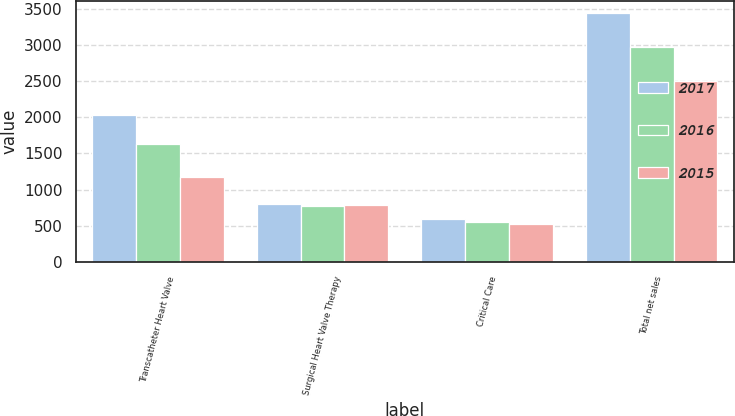<chart> <loc_0><loc_0><loc_500><loc_500><stacked_bar_chart><ecel><fcel>Transcatheter Heart Valve<fcel>Surgical Heart Valve Therapy<fcel>Critical Care<fcel>Total net sales<nl><fcel>2017<fcel>2027.2<fcel>807.1<fcel>601<fcel>3435.3<nl><fcel>2016<fcel>1628.5<fcel>774.9<fcel>560.3<fcel>2963.7<nl><fcel>2015<fcel>1180.3<fcel>785<fcel>528.4<fcel>2493.7<nl></chart> 